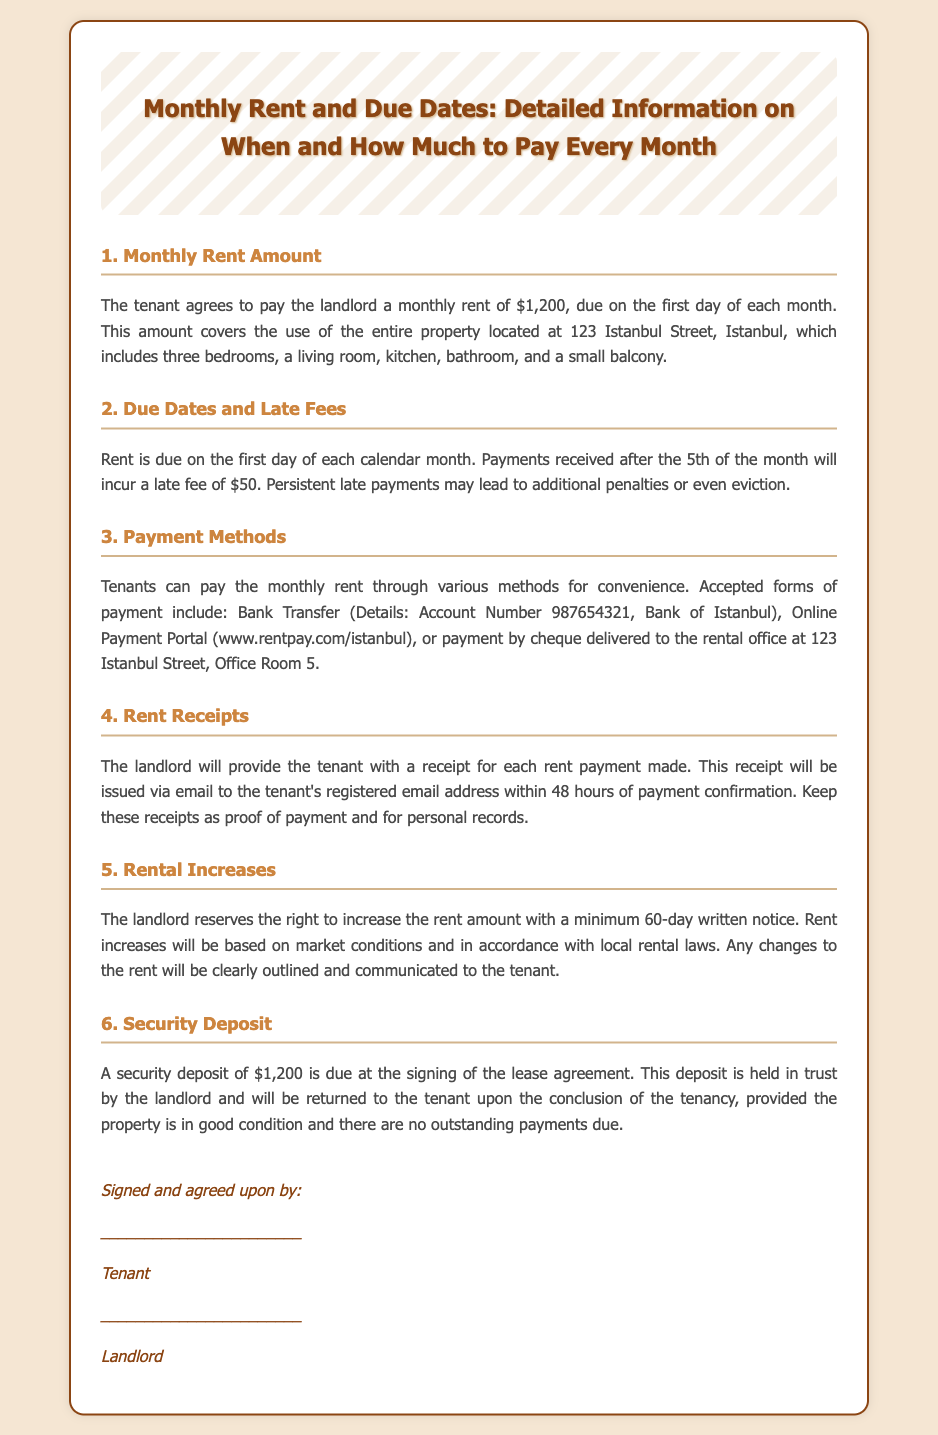What is the monthly rent amount? The document specifies the tenant agrees to pay a monthly rent of $1,200.
Answer: $1,200 When is the rent due? The rent is due on the first day of each calendar month, as stated in the document.
Answer: First day of each month What is the late fee for overdue rent? A late fee of $50 is incurred for payments received after the 5th of the month.
Answer: $50 What methods of payment are accepted? The document lists bank transfer, online payment portal, or cheque delivery as accepted payment methods.
Answer: Bank Transfer, Online Payment Portal, Cheque How much is the security deposit? The security deposit required at the signing of the lease agreement is mentioned as $1,200.
Answer: $1,200 What happens if rent is persistently paid late? The document states that persistent late payments may lead to additional penalties or even eviction.
Answer: Additional penalties or eviction What is the notice period for rental increases? The landlord must provide a minimum of 60 days' written notice for a rent increase, as per the agreement.
Answer: 60 days Who will issue the rent receipts? The landlord is responsible for providing rent receipts within 48 hours of payment confirmation.
Answer: The landlord How long will it take to receive a receipt after payment? The document mentions that receipts will be issued via email within 48 hours of payment confirmation.
Answer: 48 hours 